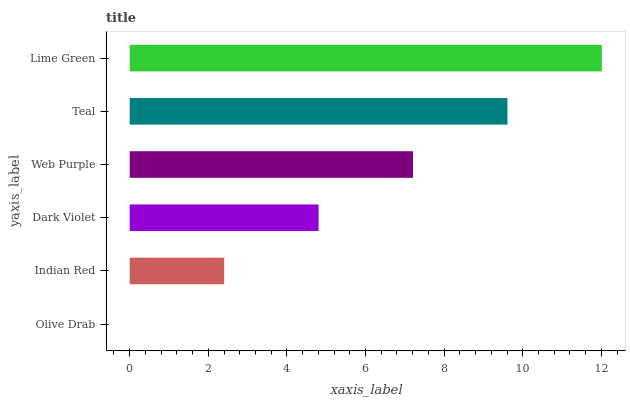Is Olive Drab the minimum?
Answer yes or no. Yes. Is Lime Green the maximum?
Answer yes or no. Yes. Is Indian Red the minimum?
Answer yes or no. No. Is Indian Red the maximum?
Answer yes or no. No. Is Indian Red greater than Olive Drab?
Answer yes or no. Yes. Is Olive Drab less than Indian Red?
Answer yes or no. Yes. Is Olive Drab greater than Indian Red?
Answer yes or no. No. Is Indian Red less than Olive Drab?
Answer yes or no. No. Is Web Purple the high median?
Answer yes or no. Yes. Is Dark Violet the low median?
Answer yes or no. Yes. Is Teal the high median?
Answer yes or no. No. Is Teal the low median?
Answer yes or no. No. 